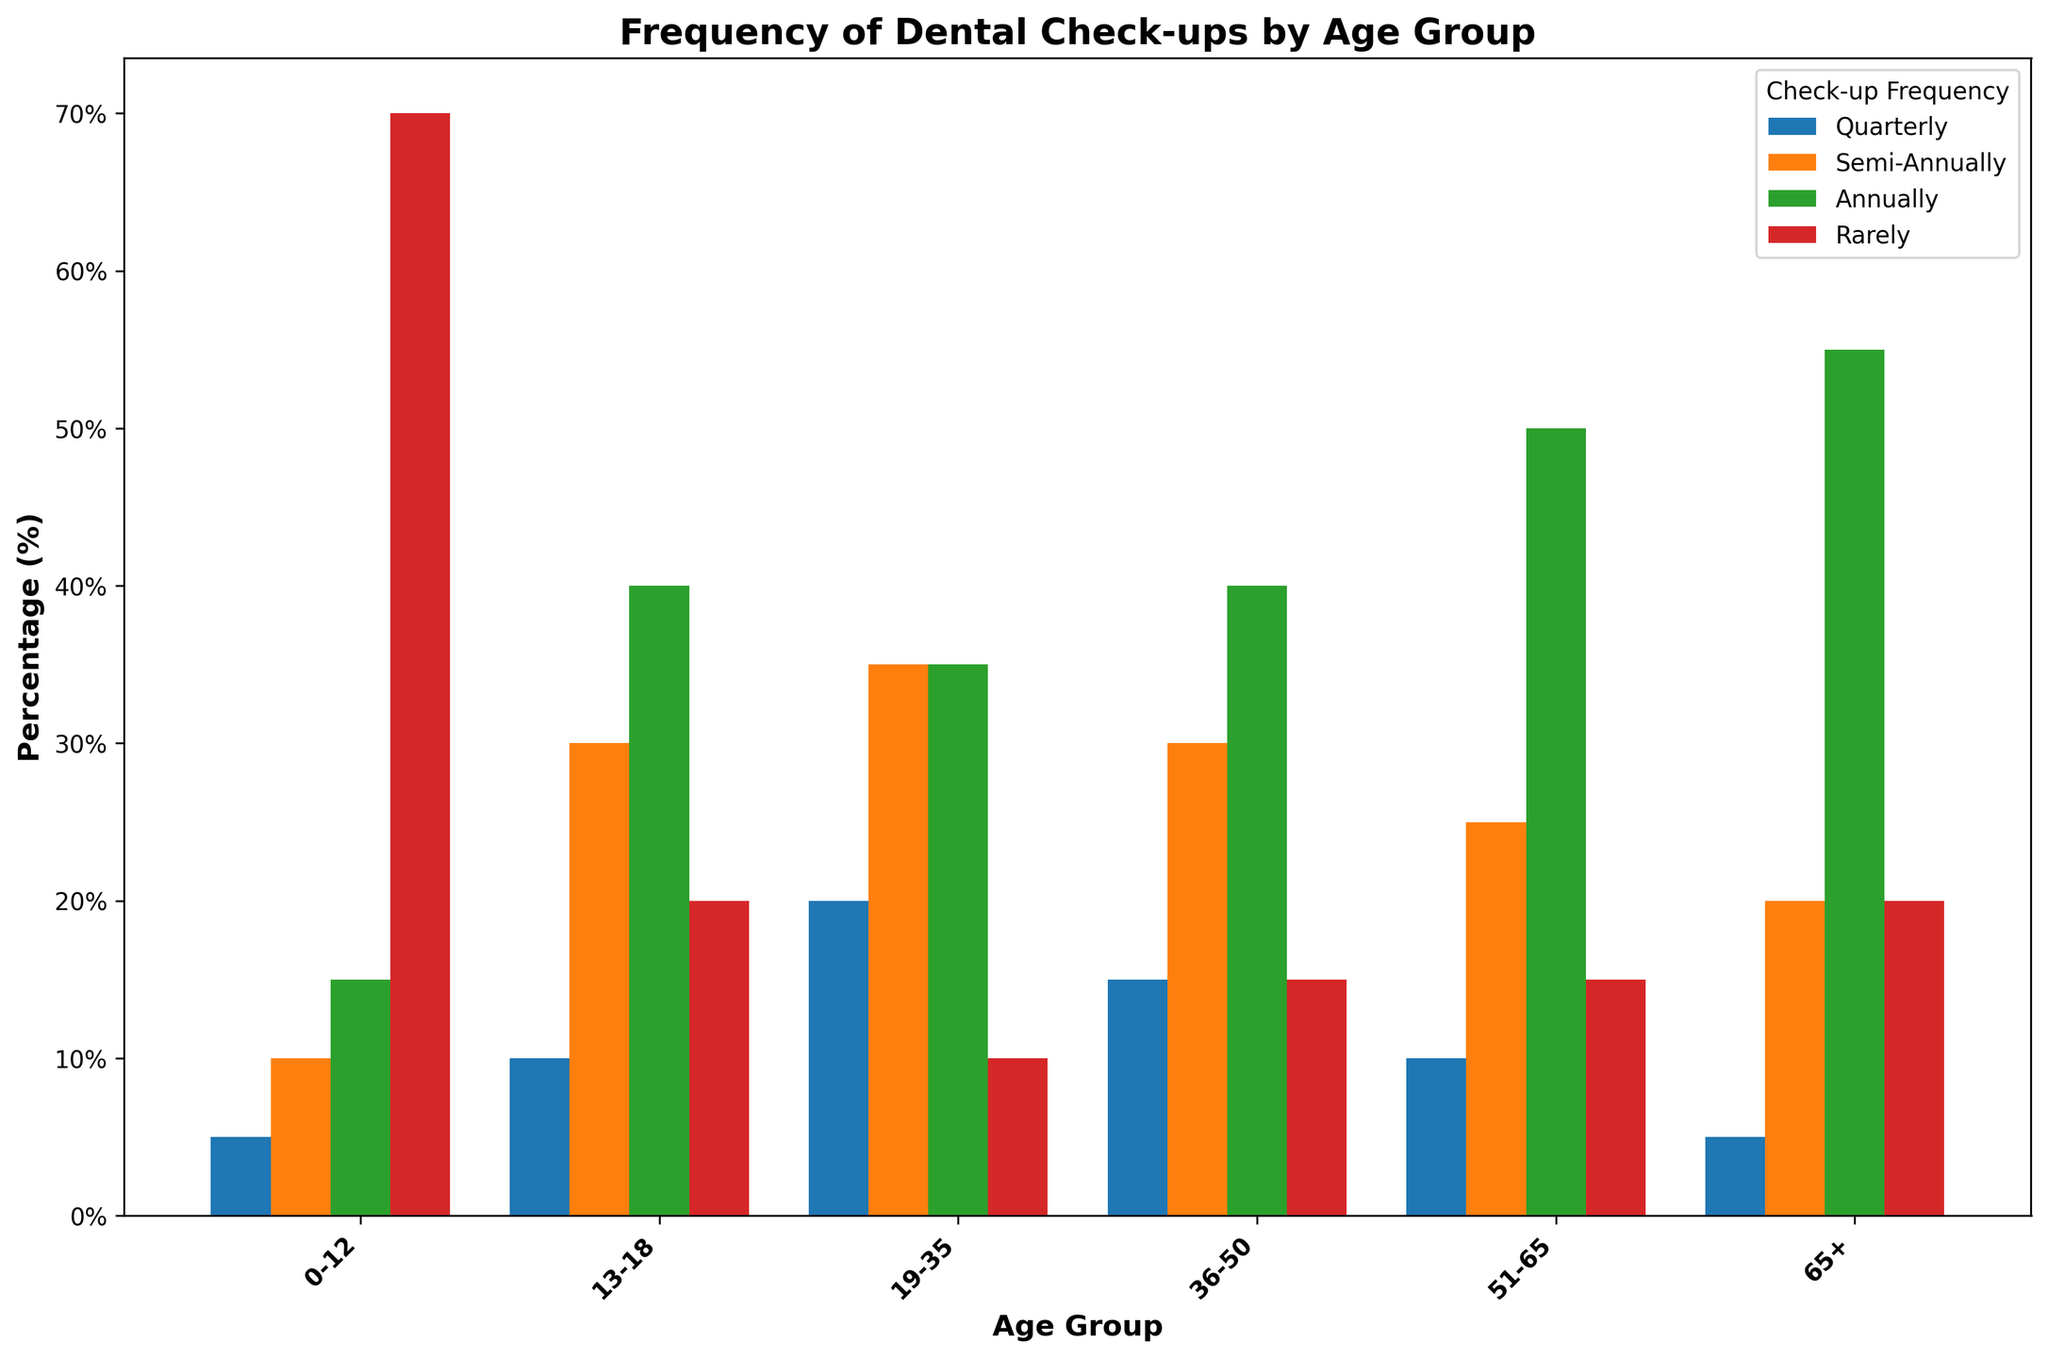What age group has the highest percentage of people who rarely visit the dentist? Look at the bars labeled "Rarely" for each age group and see which bar is the tallest. This is the 0-12 age group.
Answer: 0-12 Which age group visits the dentist quarterly the least? Check the "Quarterly" bars for each age group. The smallest bar is for the 65+ age group.
Answer: 65+ What is the total percentage of people aged 13-18 who visit the dentist either semi-annually or annually? Add the semi-annual and annual percentages for the 13-18 age group: 30% + 40% = 70%.
Answer: 70% Among the age groups 36-50 and 51-65, which group has a higher percentage of people visiting annually? Compare the "Annually" bars for the 36-50 and 51-65 age groups. The 51-65 age group has a higher percentage (50%).
Answer: 51-65 Is the percentage of people aged 19-35 visiting the dentist annually higher than the percentage of people aged 36-50 visiting rarely? Compare the annual bar for 19-35 with the rarely bar for 36-50. Both percentages are 35% and 15% respectively, so yes.
Answer: Yes What percentage of people aged 0-12 visit the dentist more than once a year (quarterly or semi-annually)? Add the quarterly and semi-annual percentages for the 0-12 age group: 5% + 10% = 15%.
Answer: 15% What is the difference in the percentage of people who visit the dentist rarely between the 0-12 and 65+ age groups? Subtract the two "Rarely" percentages: 70% (0-12) - 20% (65+) = 50%.
Answer: 50% Which age group has the closest percentage between semi-annual and annual dental visits? Check the difference between the semi-annual and annual percentages for each age group. The smallest difference is in the 19-35 age group: 35% (semi-annual) and 35% (annual), difference is 0%.
Answer: 19-35 